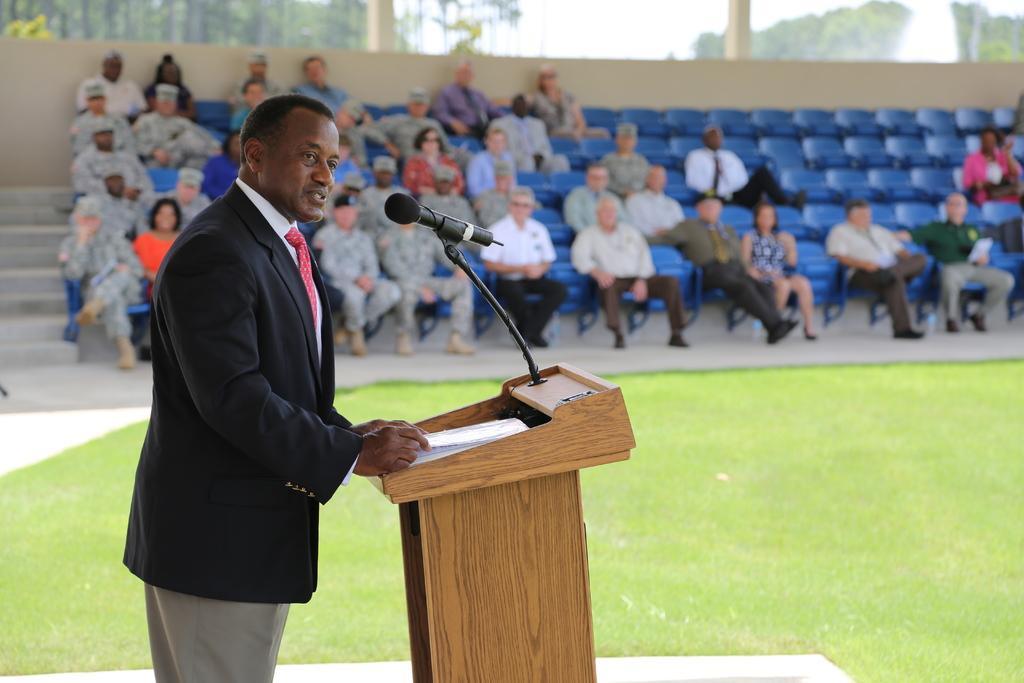Can you describe this image briefly? In this picture we can see a man wore a blazer, tie, standing at the podium and in front of him we can see a mic, papers, grass and in the background we can see a group of people sitting on chairs, wall, trees and the sky. 